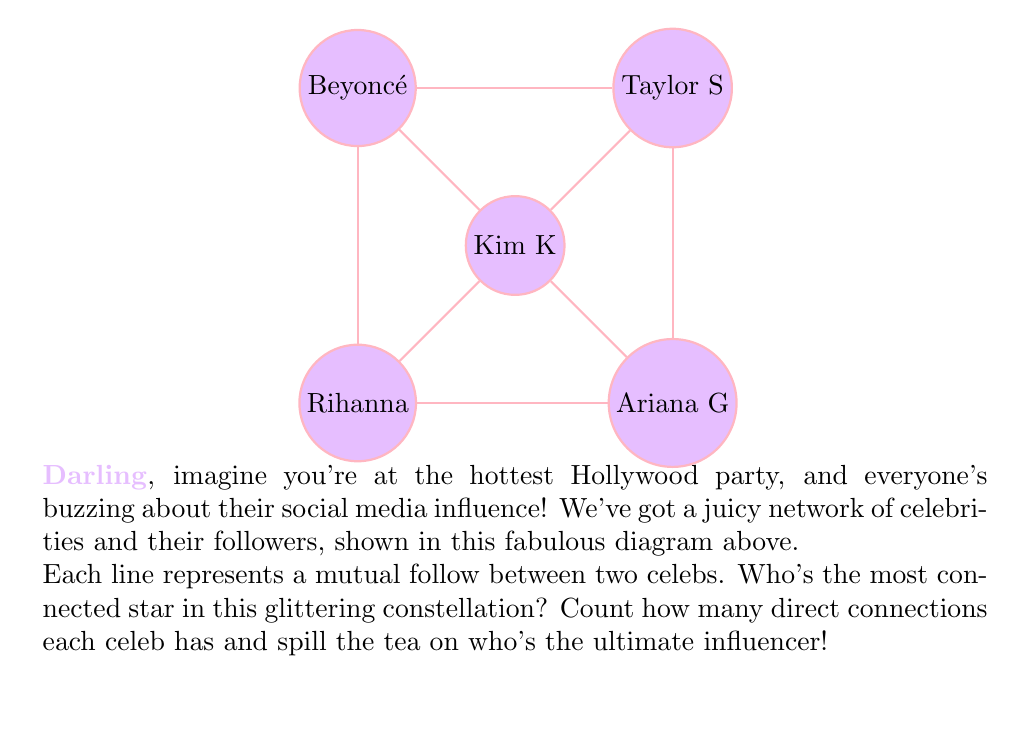Solve this math problem. Alright, darlings, let's dish out the details on this star-studded situation!

To find our queen bee of connections, we need to count how many lines are connected to each celebrity. In fancy math lingo, this is called the "degree" of each node in the graph. Let's break it down:

1. Kim K: Connected to Taylor S, Beyoncé, Rihanna, and Ariana G
   Degree: 4

2. Taylor S: Connected to Kim K, Beyoncé, and Ariana G
   Degree: 3

3. Beyoncé: Connected to Kim K, Taylor S, and Rihanna
   Degree: 3

4. Rihanna: Connected to Kim K, Beyoncé, and Ariana G
   Degree: 3

5. Ariana G: Connected to Kim K, Taylor S, and Rihanna
   Degree: 3

In mathematical terms, if we represent the degree of a celebrity $v$ as $\deg(v)$, we have:

$$
\begin{align*}
\deg(\text{Kim K}) &= 4 \\
\deg(\text{Taylor S}) &= 3 \\
\deg(\text{Beyoncé}) &= 3 \\
\deg(\text{Rihanna}) &= 3 \\
\deg(\text{Ariana G}) &= 3
\end{align*}
$$

The celebrity with the highest degree is the most connected, and therefore, the most influential in this network.
Answer: Kim K 